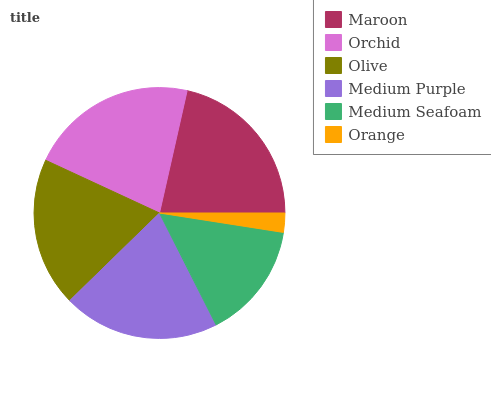Is Orange the minimum?
Answer yes or no. Yes. Is Orchid the maximum?
Answer yes or no. Yes. Is Olive the minimum?
Answer yes or no. No. Is Olive the maximum?
Answer yes or no. No. Is Orchid greater than Olive?
Answer yes or no. Yes. Is Olive less than Orchid?
Answer yes or no. Yes. Is Olive greater than Orchid?
Answer yes or no. No. Is Orchid less than Olive?
Answer yes or no. No. Is Medium Purple the high median?
Answer yes or no. Yes. Is Olive the low median?
Answer yes or no. Yes. Is Medium Seafoam the high median?
Answer yes or no. No. Is Medium Purple the low median?
Answer yes or no. No. 